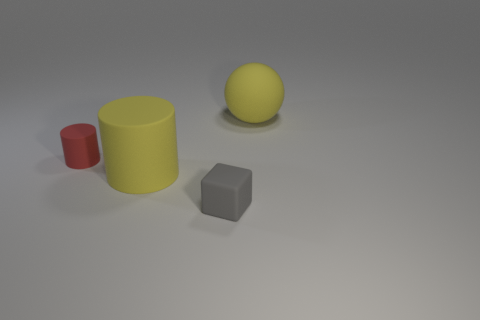Add 1 red cylinders. How many objects exist? 5 Subtract all cubes. How many objects are left? 3 Subtract all red cylinders. How many cylinders are left? 1 Subtract all blue blocks. How many yellow cylinders are left? 1 Subtract all yellow rubber cylinders. Subtract all small gray things. How many objects are left? 2 Add 2 yellow balls. How many yellow balls are left? 3 Add 1 large yellow balls. How many large yellow balls exist? 2 Subtract 1 yellow cylinders. How many objects are left? 3 Subtract all green cubes. Subtract all cyan spheres. How many cubes are left? 1 